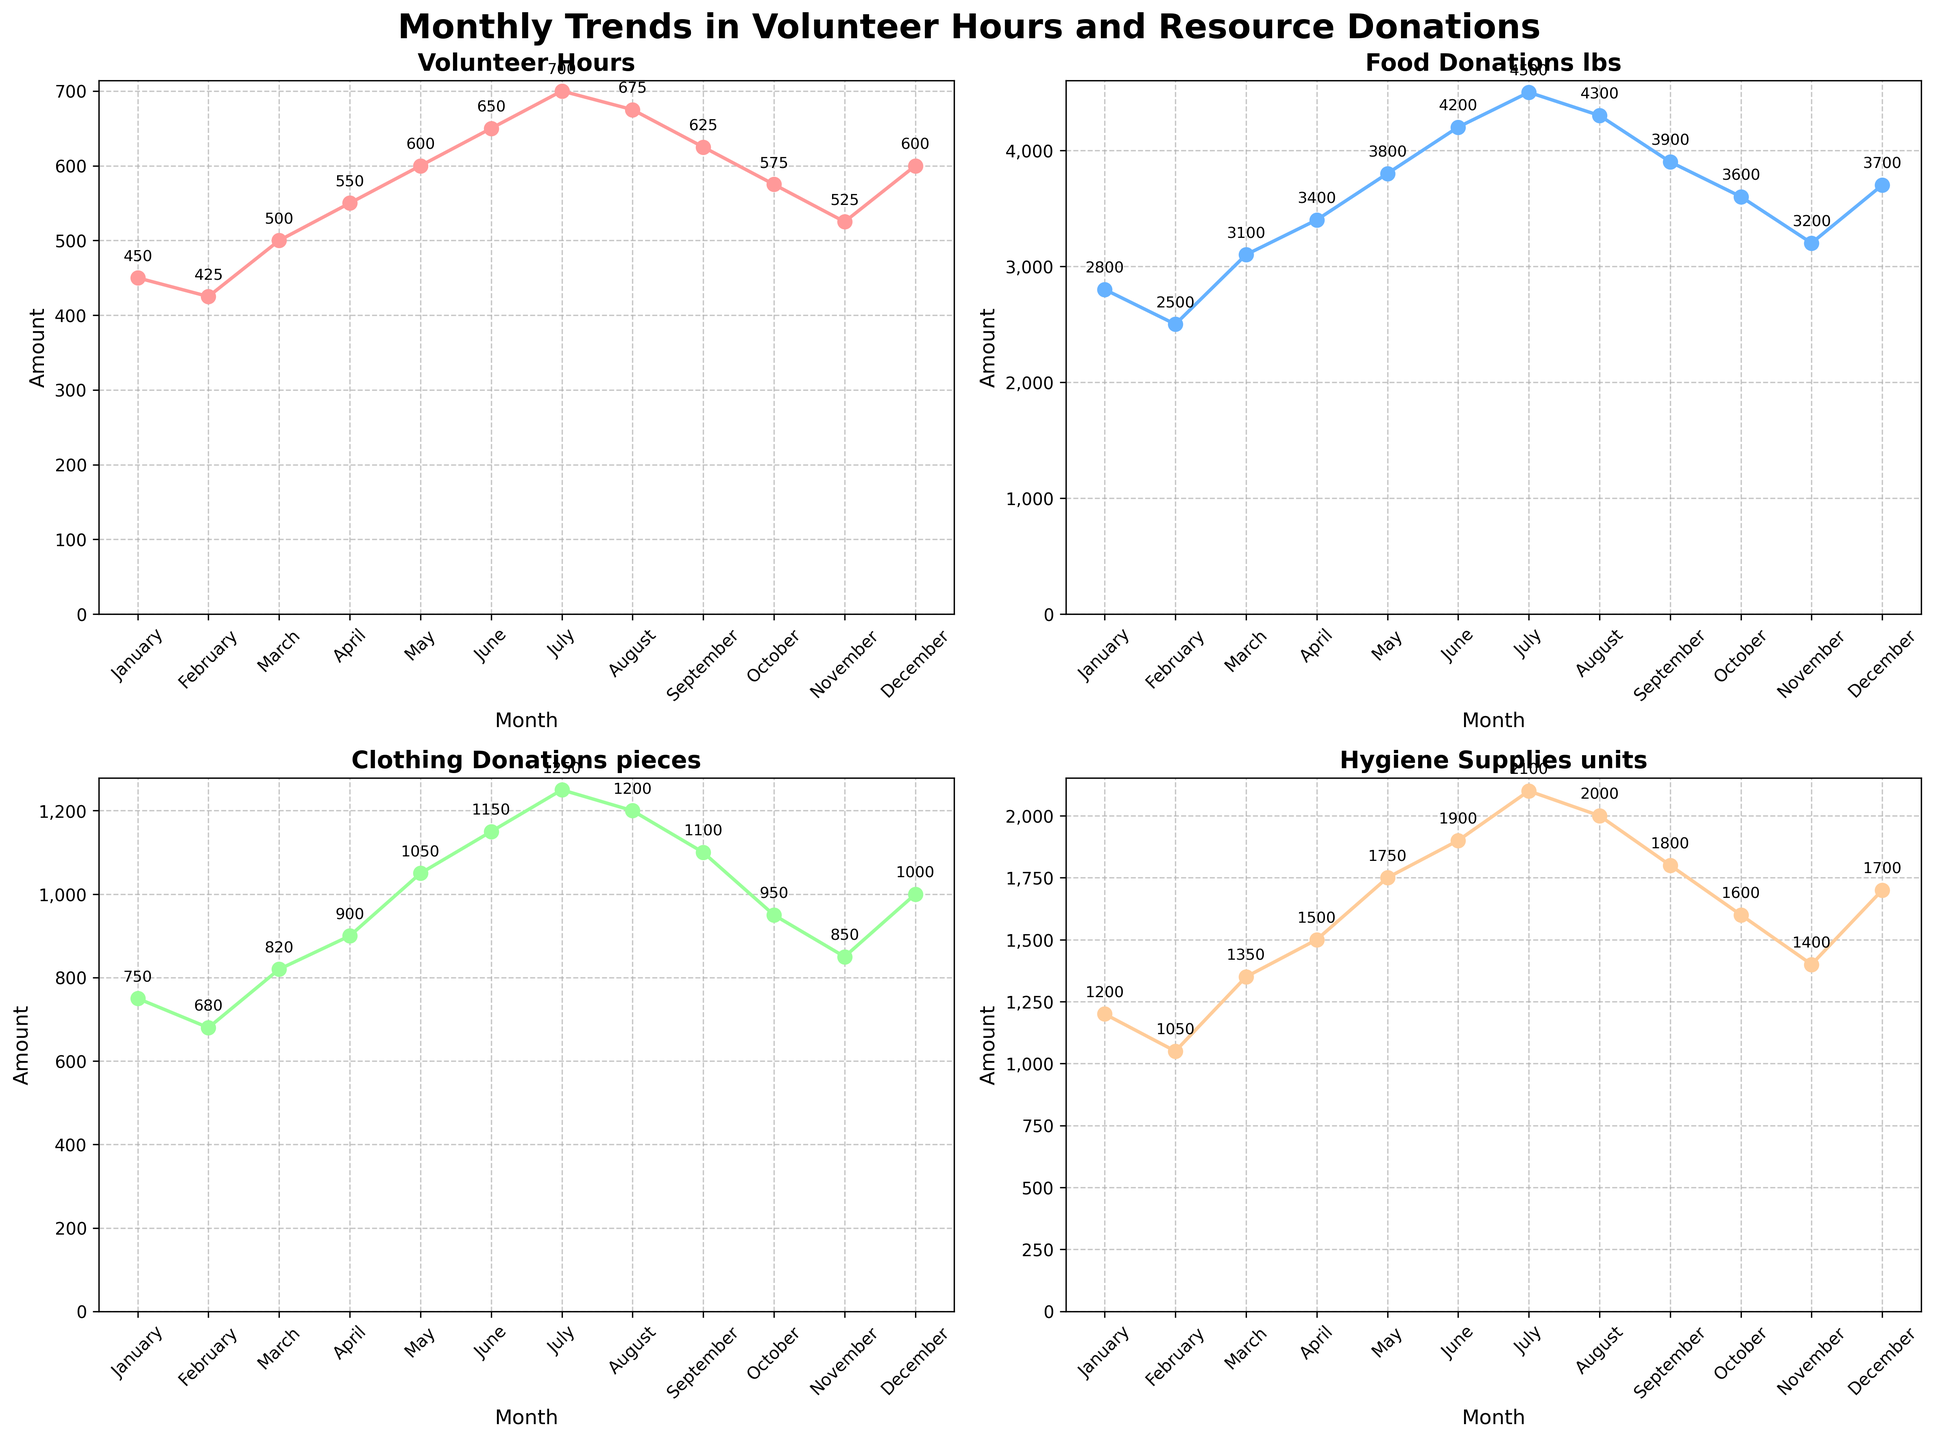Which month had the highest number of volunteer hours? The plot for Volunteer Hours shows that July had the highest number.
Answer: July What is the average food donation (in lbs) from January to June? Adding the food donations from January to June: 2800 + 2500 + 3100 + 3400 + 3800 + 4200 = 19800 lbs. Dividing by 6 months gives an average of 19800/6 = 3300 lbs.
Answer: 3300 lbs How many months had clothing donations exceed 1000 pieces? The plot for Clothing Donations shows that May, June, July, and August had more than 1000 pieces. That's 4 months.
Answer: 4 Which resource donation saw consistent increases month over month in the first half of the year? The plots for Food Donations and Hygiene Supplies both show consistent increases from January to June. Hygiene Supplies increased every month from 1200 to 1900 units, and Food Donations increased from 2800 to 4200 lbs.
Answer: Food Donations and Hygiene Supplies Compare the food donations in March and September. Which month had more, and by how much? The plot for Food Donations shows 3100 lbs in March and 3900 lbs in September. September had 3900 - 3100 = 800 lbs more.
Answer: September, 800 lbs Did any month see a decrease in hygiene supplies donations compared to the previous month? The plot for Hygiene Supplies shows no decrease; it either remained the same or increased every month.
Answer: No What is the difference in volunteer hours between April and October? The plot for Volunteer Hours shows 550 hours in April and 575 hours in October. The difference is 575 - 550 = 25 hours.
Answer: 25 hours In which month did the total resource donations (sum of food, clothing, and hygiene supplies) reach the highest, and what was the total? Adding up donations for each month and comparing them, July sees the highest total: 4500 (food) + 1250 (clothing) + 2100 (hygiene) = 7850 units.
Answer: July, 7850 units Which month had the largest increase in volunteer hours compared to the previous month? The plot for Volunteer Hours shows the largest increase from June to July, where it increased from 650 to 700 hours, a 50-hour increase.
Answer: June to July How many months had more than 3500 lbs of food donations? The plot for Food Donations shows that April through December all had more than 3500 lbs, which is 9 months.
Answer: 9 